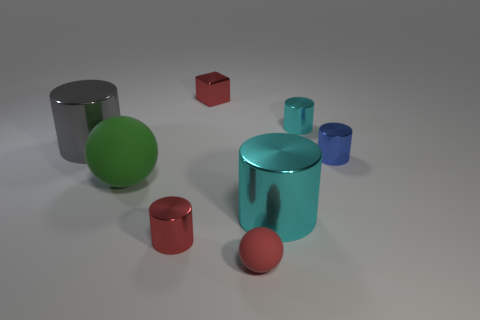Subtract all big gray metal cylinders. How many cylinders are left? 4 Add 2 cyan balls. How many objects exist? 10 Subtract all blue cylinders. How many cylinders are left? 4 Subtract 5 cylinders. How many cylinders are left? 0 Add 7 large cyan metallic objects. How many large cyan metallic objects exist? 8 Subtract 0 blue spheres. How many objects are left? 8 Subtract all blocks. How many objects are left? 7 Subtract all cyan cylinders. Subtract all blue cubes. How many cylinders are left? 3 Subtract all purple blocks. How many red balls are left? 1 Subtract all tiny gray shiny things. Subtract all green objects. How many objects are left? 7 